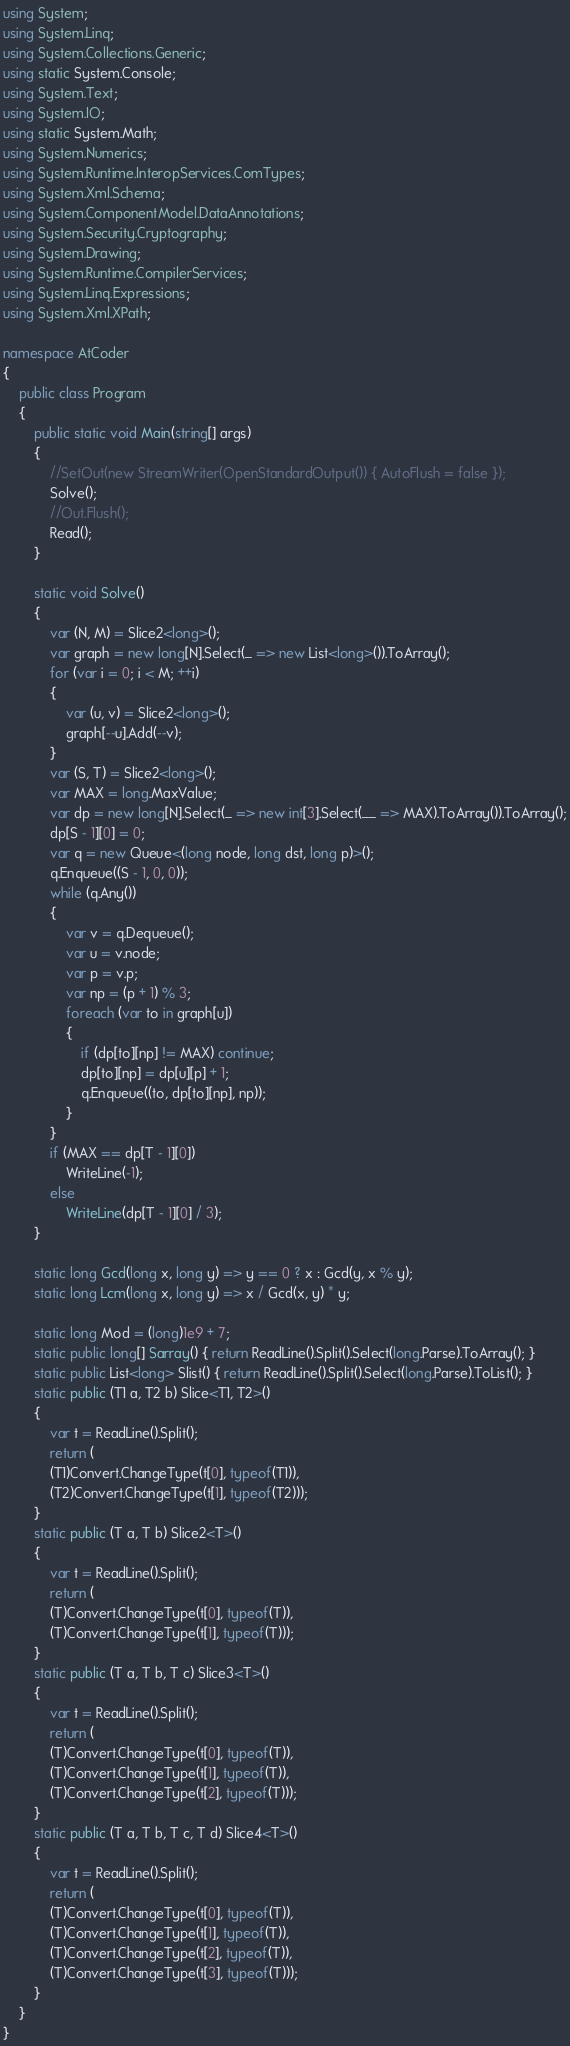Convert code to text. <code><loc_0><loc_0><loc_500><loc_500><_C#_>using System;
using System.Linq;
using System.Collections.Generic;
using static System.Console;
using System.Text;
using System.IO;
using static System.Math;
using System.Numerics;
using System.Runtime.InteropServices.ComTypes;
using System.Xml.Schema;
using System.ComponentModel.DataAnnotations;
using System.Security.Cryptography;
using System.Drawing;
using System.Runtime.CompilerServices;
using System.Linq.Expressions;
using System.Xml.XPath;

namespace AtCoder
{
    public class Program
    {
        public static void Main(string[] args)
        {
            //SetOut(new StreamWriter(OpenStandardOutput()) { AutoFlush = false });
            Solve();
            //Out.Flush();
            Read();
        }

        static void Solve()
        {
            var (N, M) = Slice2<long>();
            var graph = new long[N].Select(_ => new List<long>()).ToArray();
            for (var i = 0; i < M; ++i)
            {
                var (u, v) = Slice2<long>();
                graph[--u].Add(--v);
            }
            var (S, T) = Slice2<long>();
            var MAX = long.MaxValue;
            var dp = new long[N].Select(_ => new int[3].Select(__ => MAX).ToArray()).ToArray();
            dp[S - 1][0] = 0;
            var q = new Queue<(long node, long dst, long p)>();
            q.Enqueue((S - 1, 0, 0));
            while (q.Any())
            {
                var v = q.Dequeue();
                var u = v.node;
                var p = v.p;
                var np = (p + 1) % 3;
                foreach (var to in graph[u])
                {
                    if (dp[to][np] != MAX) continue;
                    dp[to][np] = dp[u][p] + 1;
                    q.Enqueue((to, dp[to][np], np));
                }
            }
            if (MAX == dp[T - 1][0])
                WriteLine(-1);
            else
                WriteLine(dp[T - 1][0] / 3);
        }

        static long Gcd(long x, long y) => y == 0 ? x : Gcd(y, x % y);
        static long Lcm(long x, long y) => x / Gcd(x, y) * y;

        static long Mod = (long)1e9 + 7;
        static public long[] Sarray() { return ReadLine().Split().Select(long.Parse).ToArray(); }
        static public List<long> Slist() { return ReadLine().Split().Select(long.Parse).ToList(); }
        static public (T1 a, T2 b) Slice<T1, T2>()
        {
            var t = ReadLine().Split();
            return (
            (T1)Convert.ChangeType(t[0], typeof(T1)),
            (T2)Convert.ChangeType(t[1], typeof(T2)));
        }
        static public (T a, T b) Slice2<T>()
        {
            var t = ReadLine().Split();
            return (
            (T)Convert.ChangeType(t[0], typeof(T)),
            (T)Convert.ChangeType(t[1], typeof(T)));
        }
        static public (T a, T b, T c) Slice3<T>()
        {
            var t = ReadLine().Split();
            return (
            (T)Convert.ChangeType(t[0], typeof(T)),
            (T)Convert.ChangeType(t[1], typeof(T)),
            (T)Convert.ChangeType(t[2], typeof(T)));
        }
        static public (T a, T b, T c, T d) Slice4<T>()
        {
            var t = ReadLine().Split();
            return (
            (T)Convert.ChangeType(t[0], typeof(T)),
            (T)Convert.ChangeType(t[1], typeof(T)),
            (T)Convert.ChangeType(t[2], typeof(T)),
            (T)Convert.ChangeType(t[3], typeof(T)));
        }
    }
}</code> 